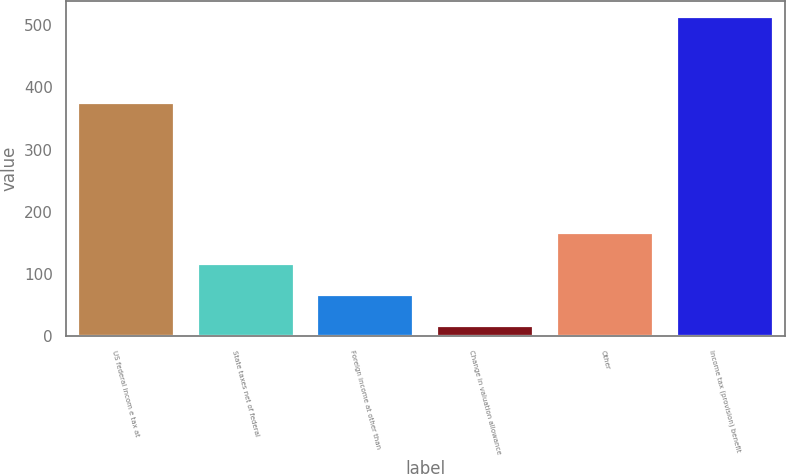Convert chart to OTSL. <chart><loc_0><loc_0><loc_500><loc_500><bar_chart><fcel>US federal incom e tax at<fcel>State taxes net of federal<fcel>Foreign income at other than<fcel>Change in valuation allowance<fcel>Other<fcel>Income tax (provision) benefit<nl><fcel>375.2<fcel>116.04<fcel>66.32<fcel>16.6<fcel>165.76<fcel>513.8<nl></chart> 